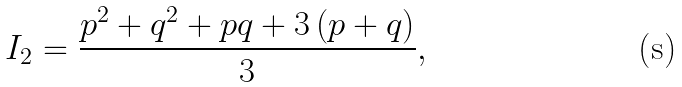<formula> <loc_0><loc_0><loc_500><loc_500>I _ { 2 } = \frac { p ^ { 2 } + q ^ { 2 } + p q + 3 \left ( p + q \right ) } { 3 } ,</formula> 